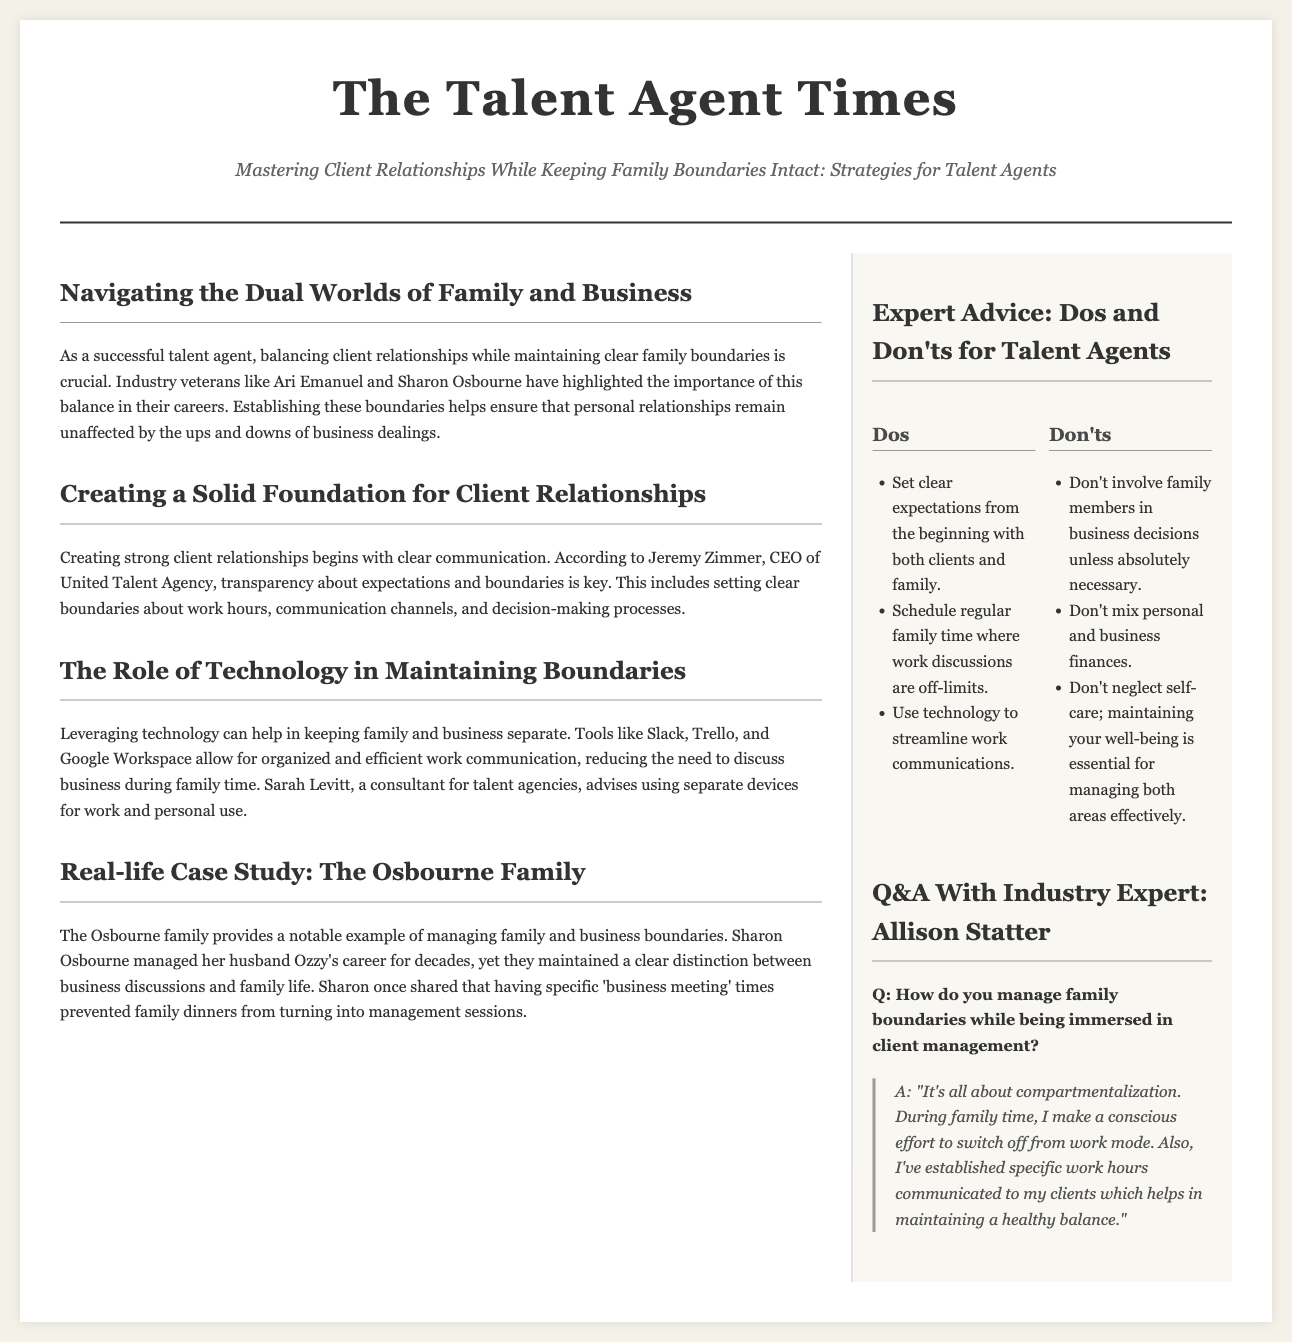What is the title of the article? The title is prominently displayed at the top of the document.
Answer: Mastering Client Relationships While Keeping Family Boundaries Intact: Strategies for Talent Agents Who is the CEO of United Talent Agency? The document mentions Jeremy Zimmer as the CEO.
Answer: Jeremy Zimmer What technology tools are recommended to maintain boundaries? The article lists specific tools that can help in managing work communications.
Answer: Slack, Trello, and Google Workspace What strategy did Sharon Osbourne use to separate family and business discussions? The document provides insights into Sharon Osbourne's method of maintaining boundaries.
Answer: Specific 'business meeting' times What advice does Allison Statter give for managing family time? The quote from Allison Statter explains her approach to work-life balance.
Answer: Compartmentalization How many key 'dos' are suggested for talent agents? The document lists three 'dos' in the sidebar section.
Answer: Three 